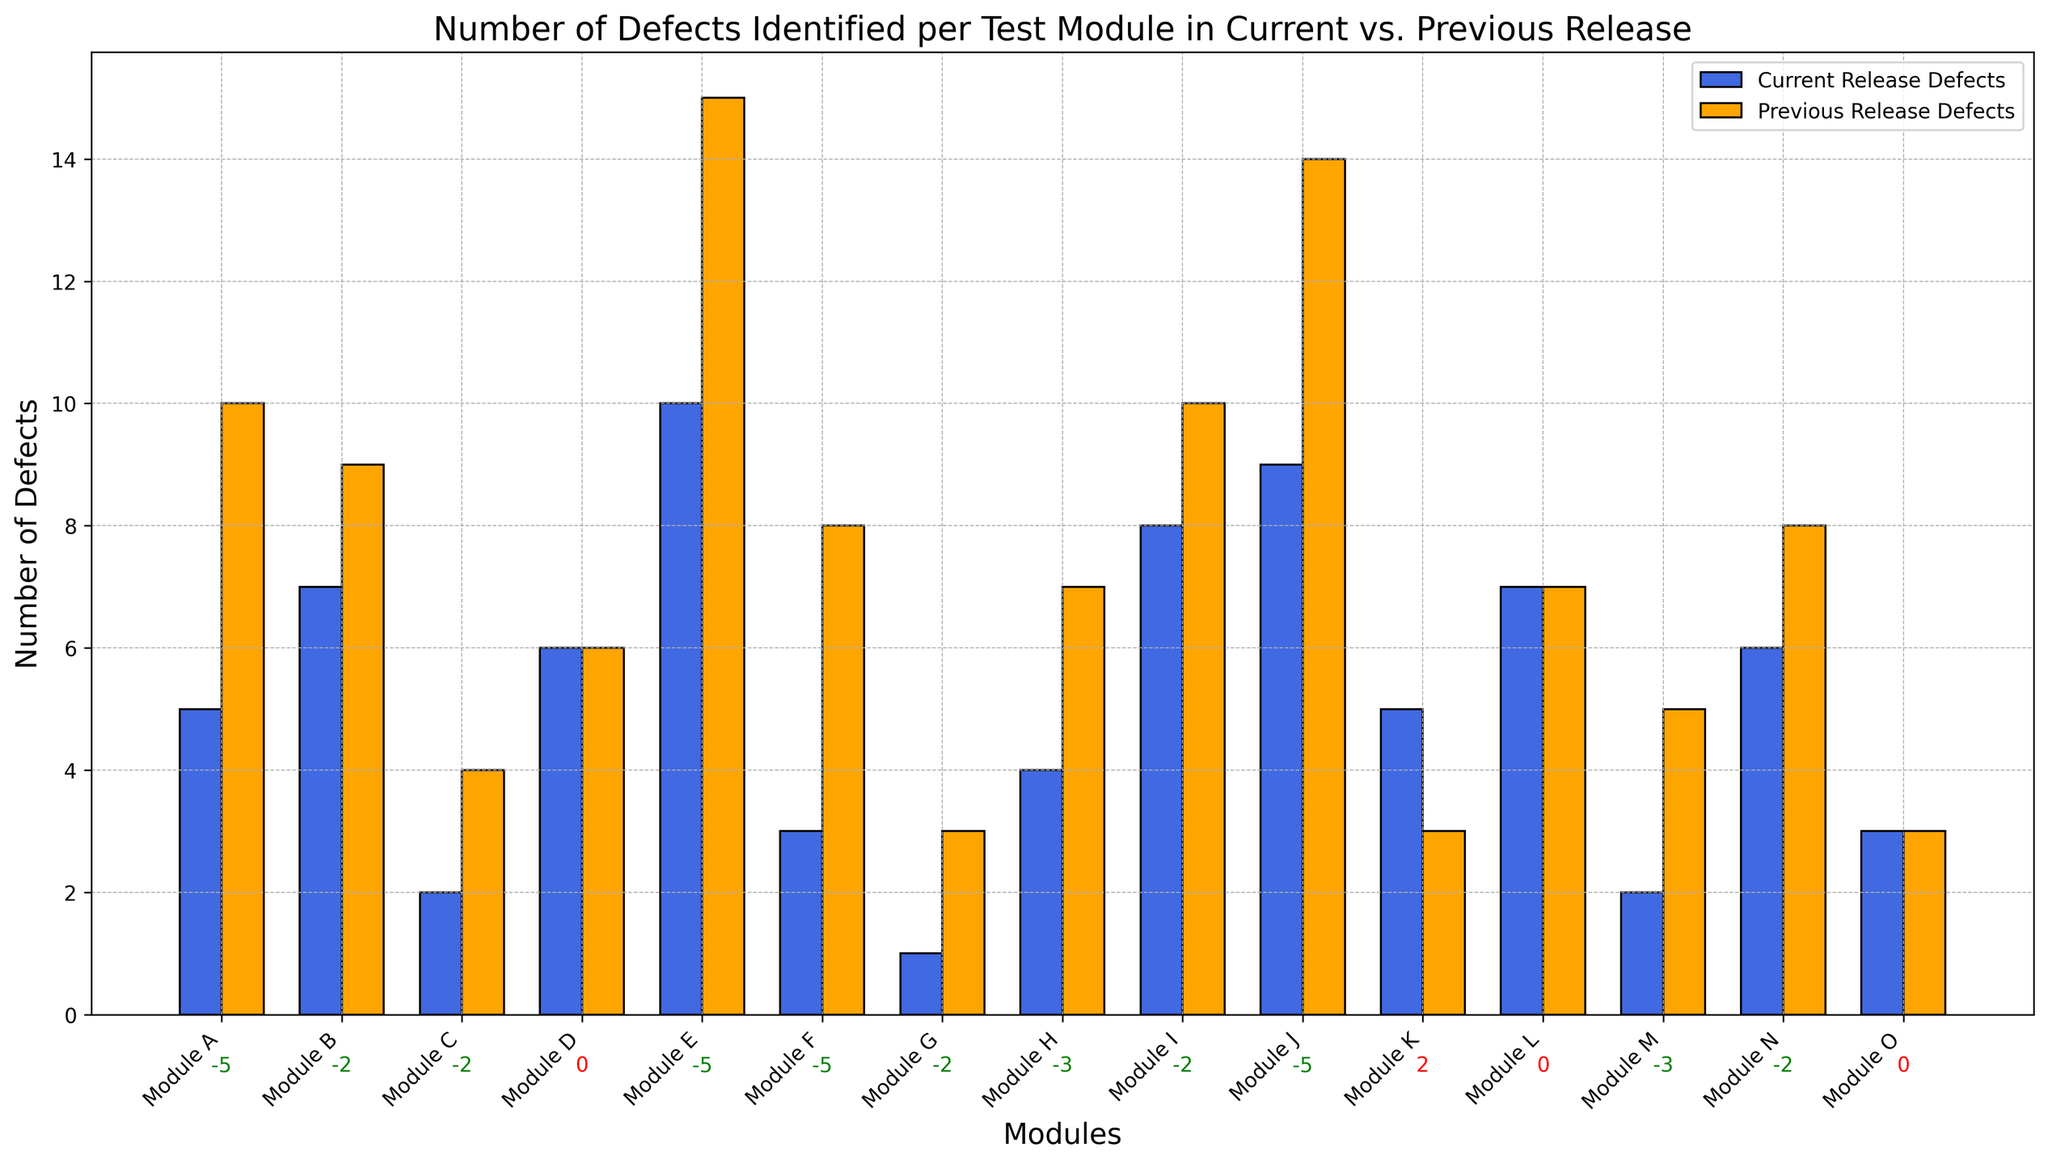Which module has the largest decline in defects? To find the module with the largest decline, you should look for the smallest value in the 'Decline in Defects' category. This corresponds to the most negative number. Modules A, E, F, and J all have a decline of -5.
Answer: Modules A, E, F, J Which module had no change in the number of defects between the current and previous release? To find the module with no change, look for the module where 'Decline in Defects' is 0. This means the number of defects in both releases is the same. Modules D, L, and O have no change.
Answer: Modules D, L, O Which module has the highest number of defects in the current release? To find this, look for the tallest bar in the 'Current Release Defects' series. The tallest bar has 10 defects, which corresponds to Module E.
Answer: Module E What is the total decline in defects for modules B and C combined? To find the total decline, add the declines for modules B and C. The decline for module B is -2, and for module C, it's also -2. -2 + (-2) = -4.
Answer: -4 Which module saw an increase in defects from the previous to the current release? Look for the modules where the 'Decline in Defects' is a positive number. Module K has a value of 2, indicating an increase in defects.
Answer: Module K What is the average decline in defects across all modules that saw a decline? To calculate this, sum all the negative values in the 'Decline in Defects' column and divide by the number of these values. Summing the declines: -5 + (-2) + (-2) + (-5) + (-5) + (-2) + (-3) + (-2) + (-5) + (-3) + (-2) = -36. There are 11 such values. -36 / 11 ≈ -3.27.
Answer: -3.27 What is the difference in the number of defects between the current and previous release for Module I? Subtract the number of defects in the current release from the previous release: 10 (previous) - 8 (current) = 2.
Answer: 2 Which module saw the most improvement (biggest decline in defects) relative to its previous release defects? To find this, compute the ratio of decline to previous release defects for each module and identify the maximum. Module E: -5/15 = -0.333, Module A: -5/10 = -0.5, etc. Module F has the largest ratio: -5/8 = -0.625.
Answer: Module F How many modules have the same number of defects in both the current and previous release? Count the number of modules where 'Decline in Defects' is 0. There are three such modules: D, L, and O.
Answer: 3 